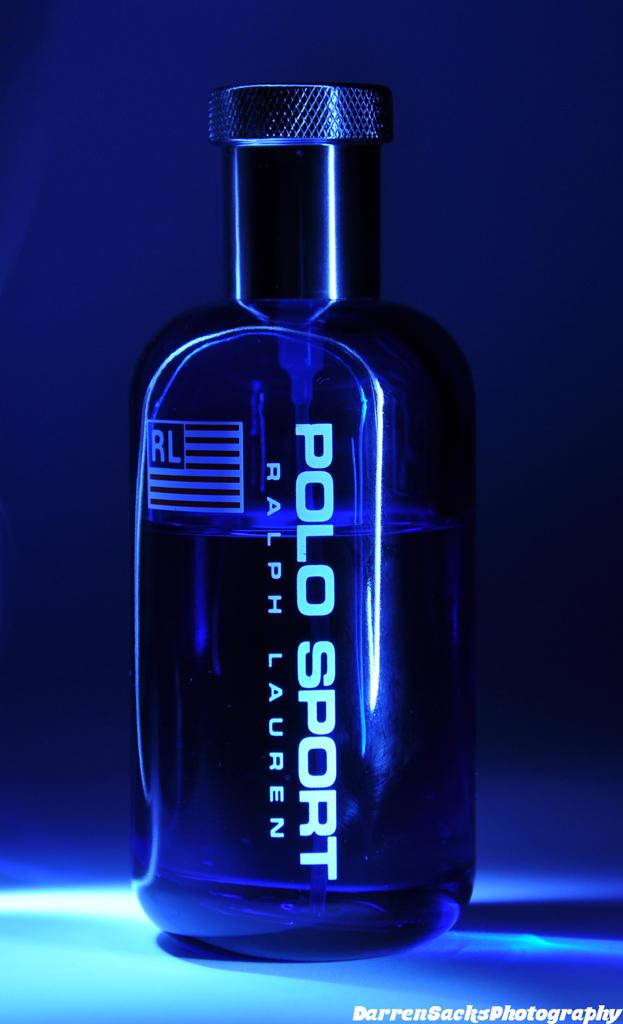What object is the main focus of the image? There is a perfume bottle in the image. What color is the background of the image? The background of the image is blue. Where is the page of the book located in the image? There is no page of a book present in the image; it only features a perfume bottle against a blue background. 